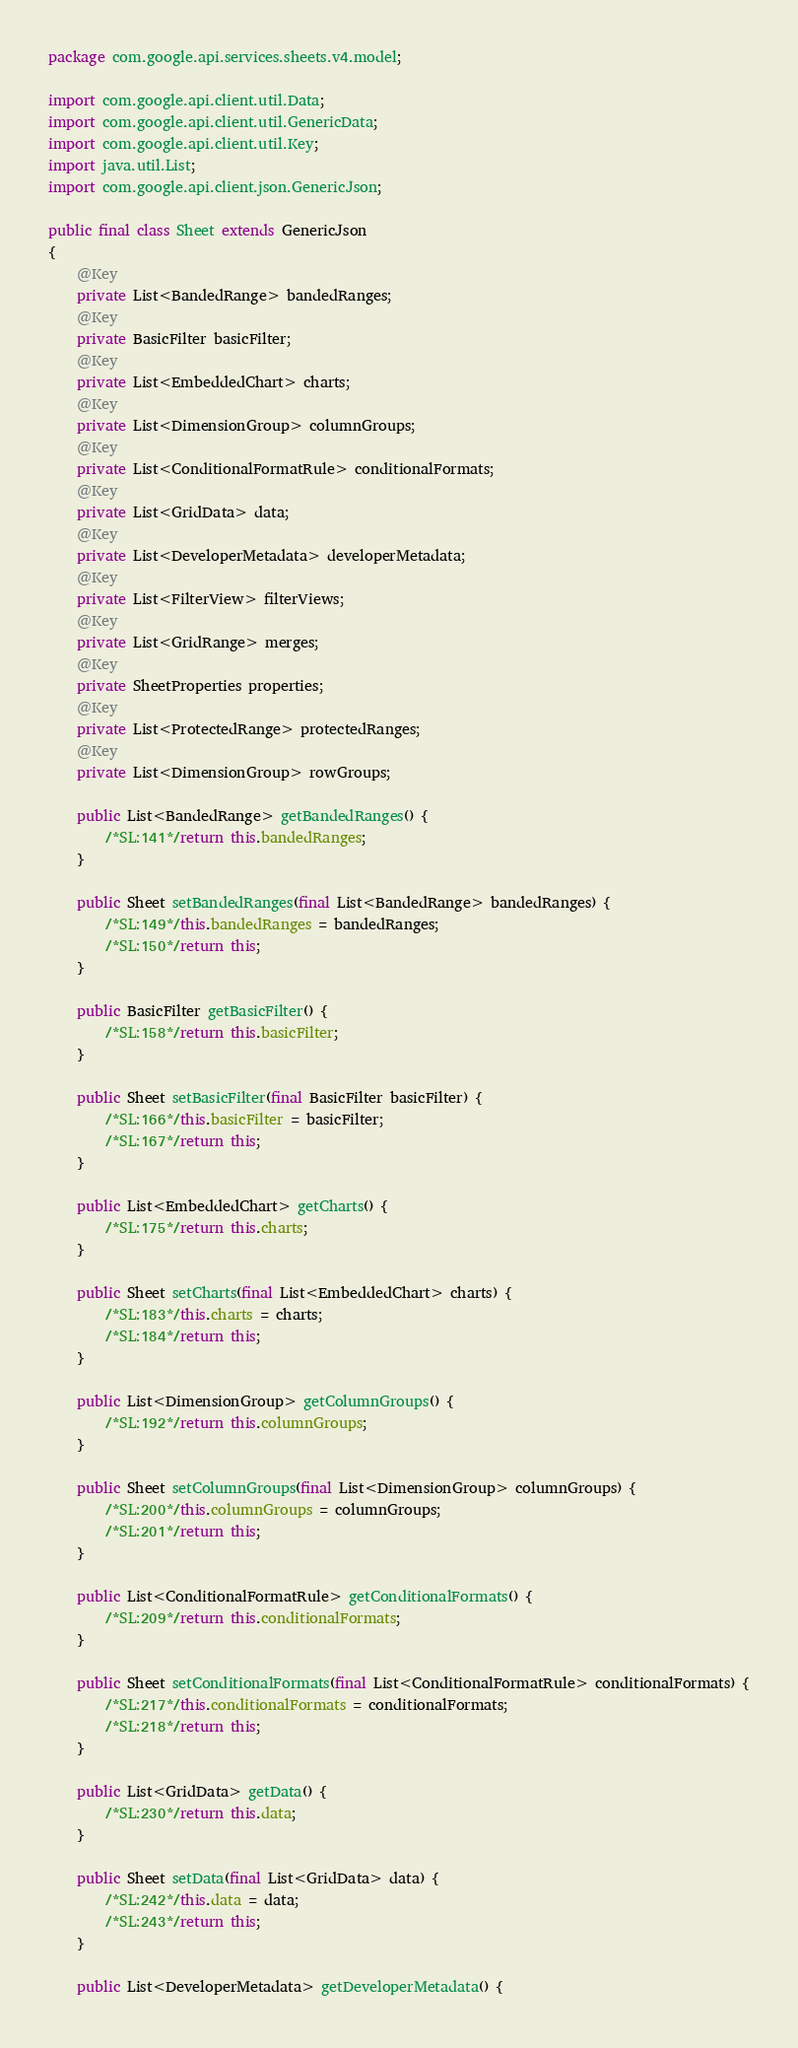<code> <loc_0><loc_0><loc_500><loc_500><_Java_>package com.google.api.services.sheets.v4.model;

import com.google.api.client.util.Data;
import com.google.api.client.util.GenericData;
import com.google.api.client.util.Key;
import java.util.List;
import com.google.api.client.json.GenericJson;

public final class Sheet extends GenericJson
{
    @Key
    private List<BandedRange> bandedRanges;
    @Key
    private BasicFilter basicFilter;
    @Key
    private List<EmbeddedChart> charts;
    @Key
    private List<DimensionGroup> columnGroups;
    @Key
    private List<ConditionalFormatRule> conditionalFormats;
    @Key
    private List<GridData> data;
    @Key
    private List<DeveloperMetadata> developerMetadata;
    @Key
    private List<FilterView> filterViews;
    @Key
    private List<GridRange> merges;
    @Key
    private SheetProperties properties;
    @Key
    private List<ProtectedRange> protectedRanges;
    @Key
    private List<DimensionGroup> rowGroups;
    
    public List<BandedRange> getBandedRanges() {
        /*SL:141*/return this.bandedRanges;
    }
    
    public Sheet setBandedRanges(final List<BandedRange> bandedRanges) {
        /*SL:149*/this.bandedRanges = bandedRanges;
        /*SL:150*/return this;
    }
    
    public BasicFilter getBasicFilter() {
        /*SL:158*/return this.basicFilter;
    }
    
    public Sheet setBasicFilter(final BasicFilter basicFilter) {
        /*SL:166*/this.basicFilter = basicFilter;
        /*SL:167*/return this;
    }
    
    public List<EmbeddedChart> getCharts() {
        /*SL:175*/return this.charts;
    }
    
    public Sheet setCharts(final List<EmbeddedChart> charts) {
        /*SL:183*/this.charts = charts;
        /*SL:184*/return this;
    }
    
    public List<DimensionGroup> getColumnGroups() {
        /*SL:192*/return this.columnGroups;
    }
    
    public Sheet setColumnGroups(final List<DimensionGroup> columnGroups) {
        /*SL:200*/this.columnGroups = columnGroups;
        /*SL:201*/return this;
    }
    
    public List<ConditionalFormatRule> getConditionalFormats() {
        /*SL:209*/return this.conditionalFormats;
    }
    
    public Sheet setConditionalFormats(final List<ConditionalFormatRule> conditionalFormats) {
        /*SL:217*/this.conditionalFormats = conditionalFormats;
        /*SL:218*/return this;
    }
    
    public List<GridData> getData() {
        /*SL:230*/return this.data;
    }
    
    public Sheet setData(final List<GridData> data) {
        /*SL:242*/this.data = data;
        /*SL:243*/return this;
    }
    
    public List<DeveloperMetadata> getDeveloperMetadata() {</code> 